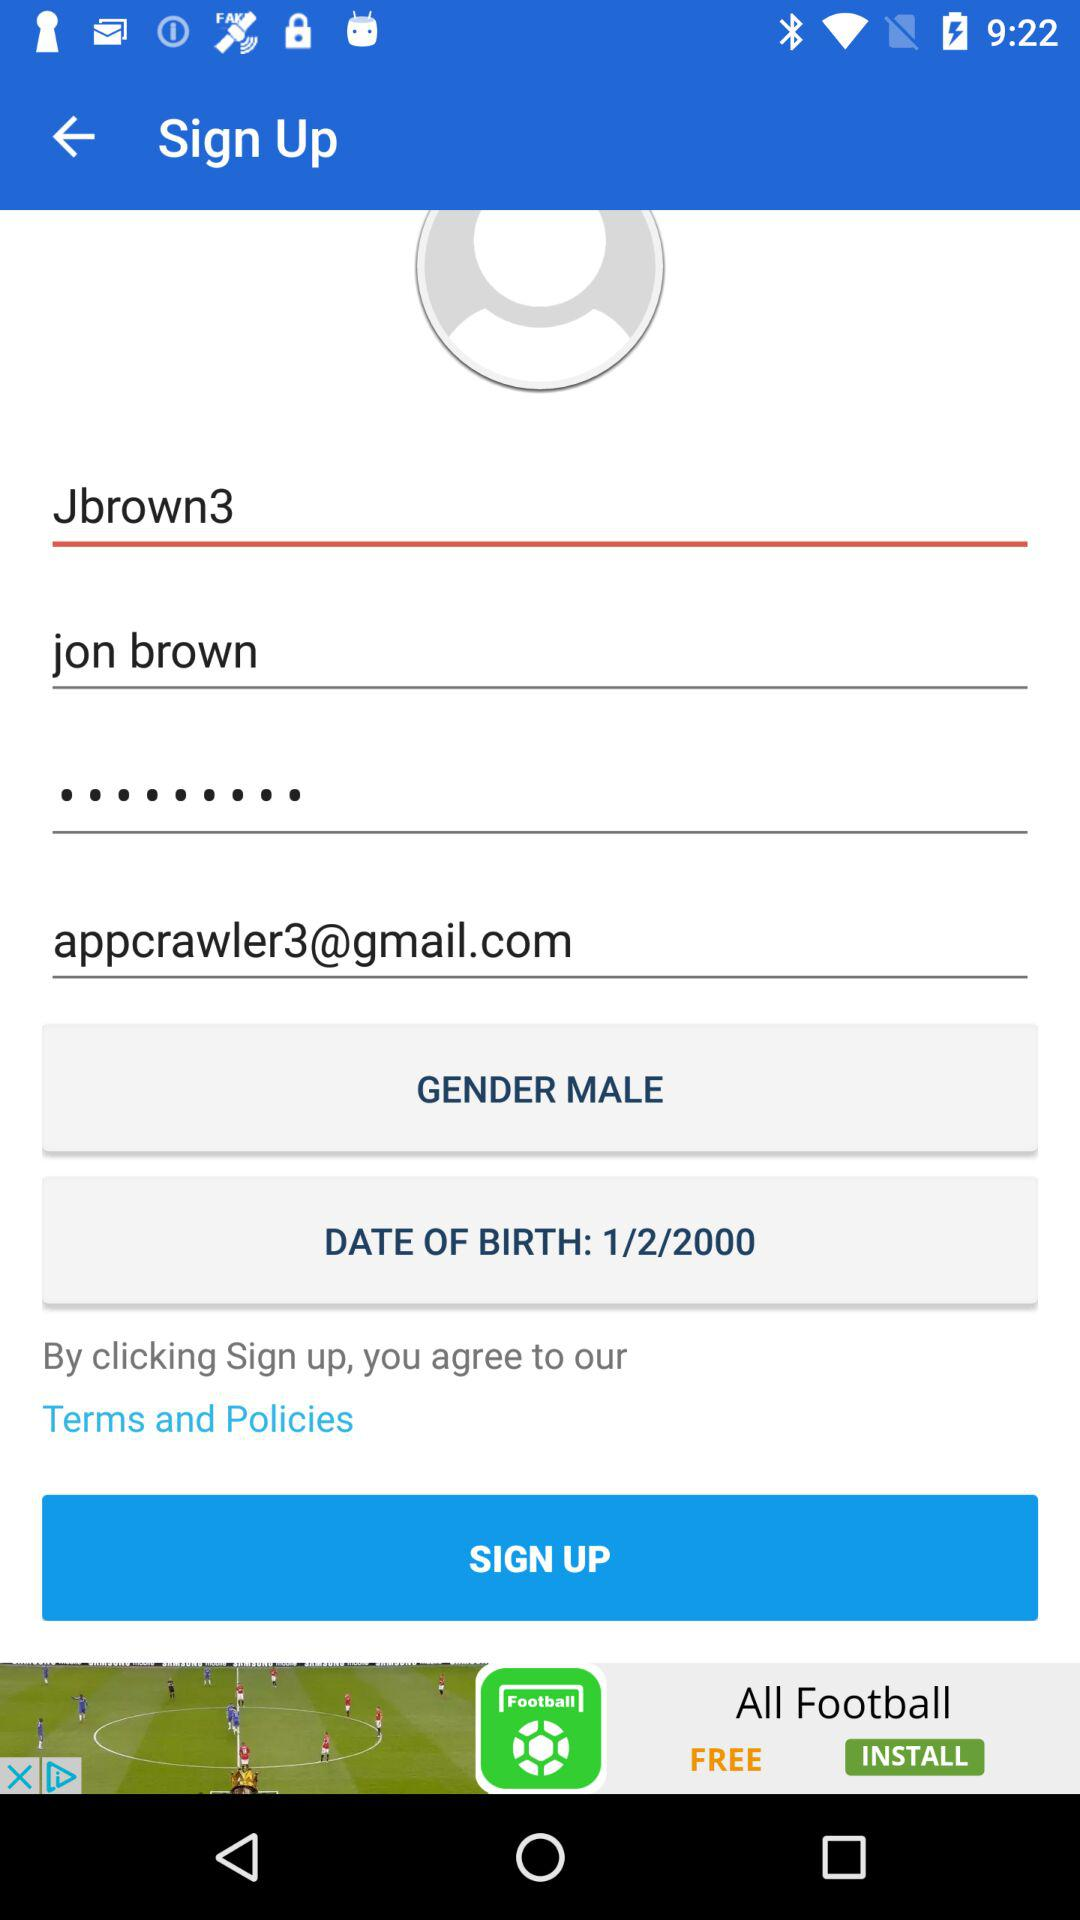What are the requirements for the password?
When the provided information is insufficient, respond with <no answer>. <no answer> 